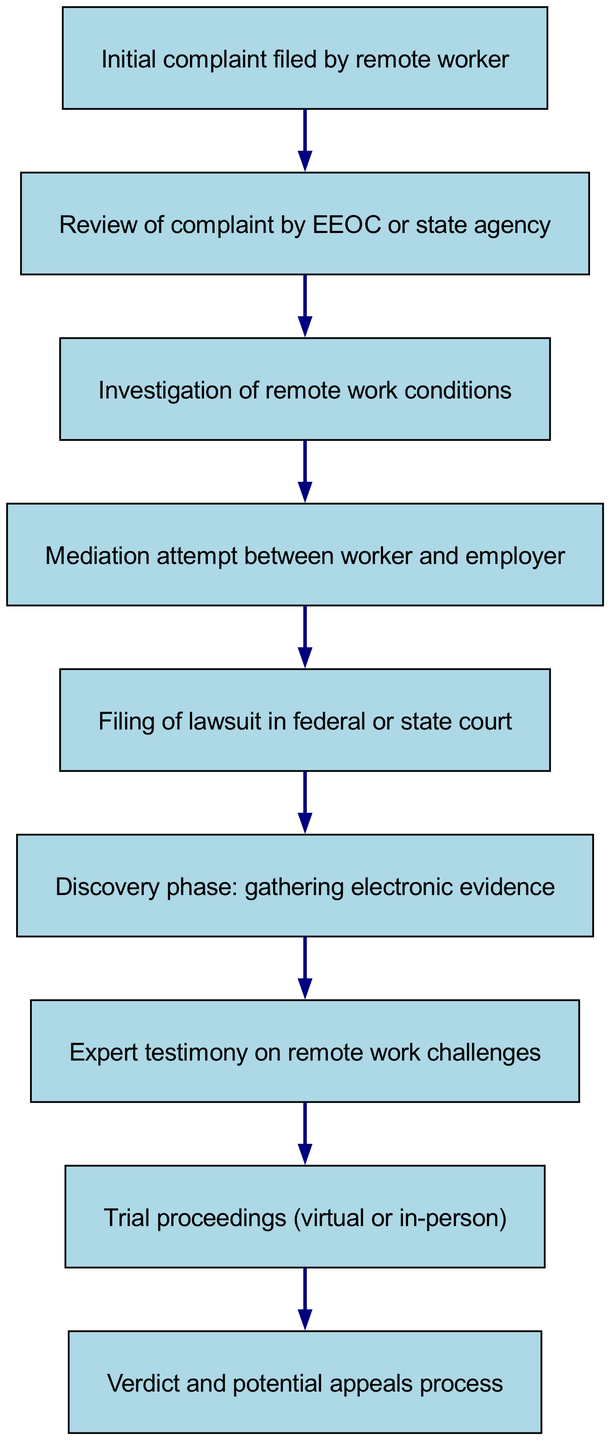What is the first stage in a remote worker's rights lawsuit? The diagram indicates that the initial complaint filed by the remote worker is the first stage in the process. This is the starting point for the entire flow.
Answer: Initial complaint filed by remote worker How many stages are there in total? By counting the nodes listed in the diagram, there are nine distinct stages outlined from the initial complaint to the final verdict.
Answer: 9 Which stage follows the mediation attempt? The diagram shows that the stage that directly follows the mediation attempt is the filing of a lawsuit in federal or state court. This is indicated by the directed edge connecting those two stages.
Answer: Filing of lawsuit in federal or state court What type of testimony is included in the lawsuit process? The diagram lists expert testimony on remote work challenges as a specific stage during the lawsuit process, suggesting that experts may provide insights on the complexities of remote work in relation to workers' rights.
Answer: Expert testimony on remote work challenges Describe the relationship between the investigation of remote work conditions and the mediation attempt. The relationship shows that the investigation of remote work conditions occurs prior to the mediation attempt, suggesting that the investigation is critical information that might inform the mediation process. This helps clarify the context of the dispute.
Answer: Investigation precedes mediation Which stage might involve virtual proceedings? The trial proceedings, as stated in the diagram, include both virtual or in-person formats, indicating the flexibility in how trials can be conducted given modern circumstances.
Answer: Trial proceedings (virtual or in-person) What is the last stage of the lawsuit process? According to the diagram, the last stage of the process is the verdict and potential appeals process, marking the conclusion of the lawsuit trajectory.
Answer: Verdict and potential appeals process How many stages directly involve evidence gathering? The diagram indicates that the discovery phase, which is the sixth stage, involves gathering electronic evidence, and this is the only stage that explicitly states evidence gathering. Therefore, there is one stage that does this.
Answer: 1 What stage occurs directly after the filing of a lawsuit? Following the filing of a lawsuit in federal or state court, the next stage is the discovery phase, which involves gathering electronic evidence relevant to the case.
Answer: Discovery phase: gathering electronic evidence 